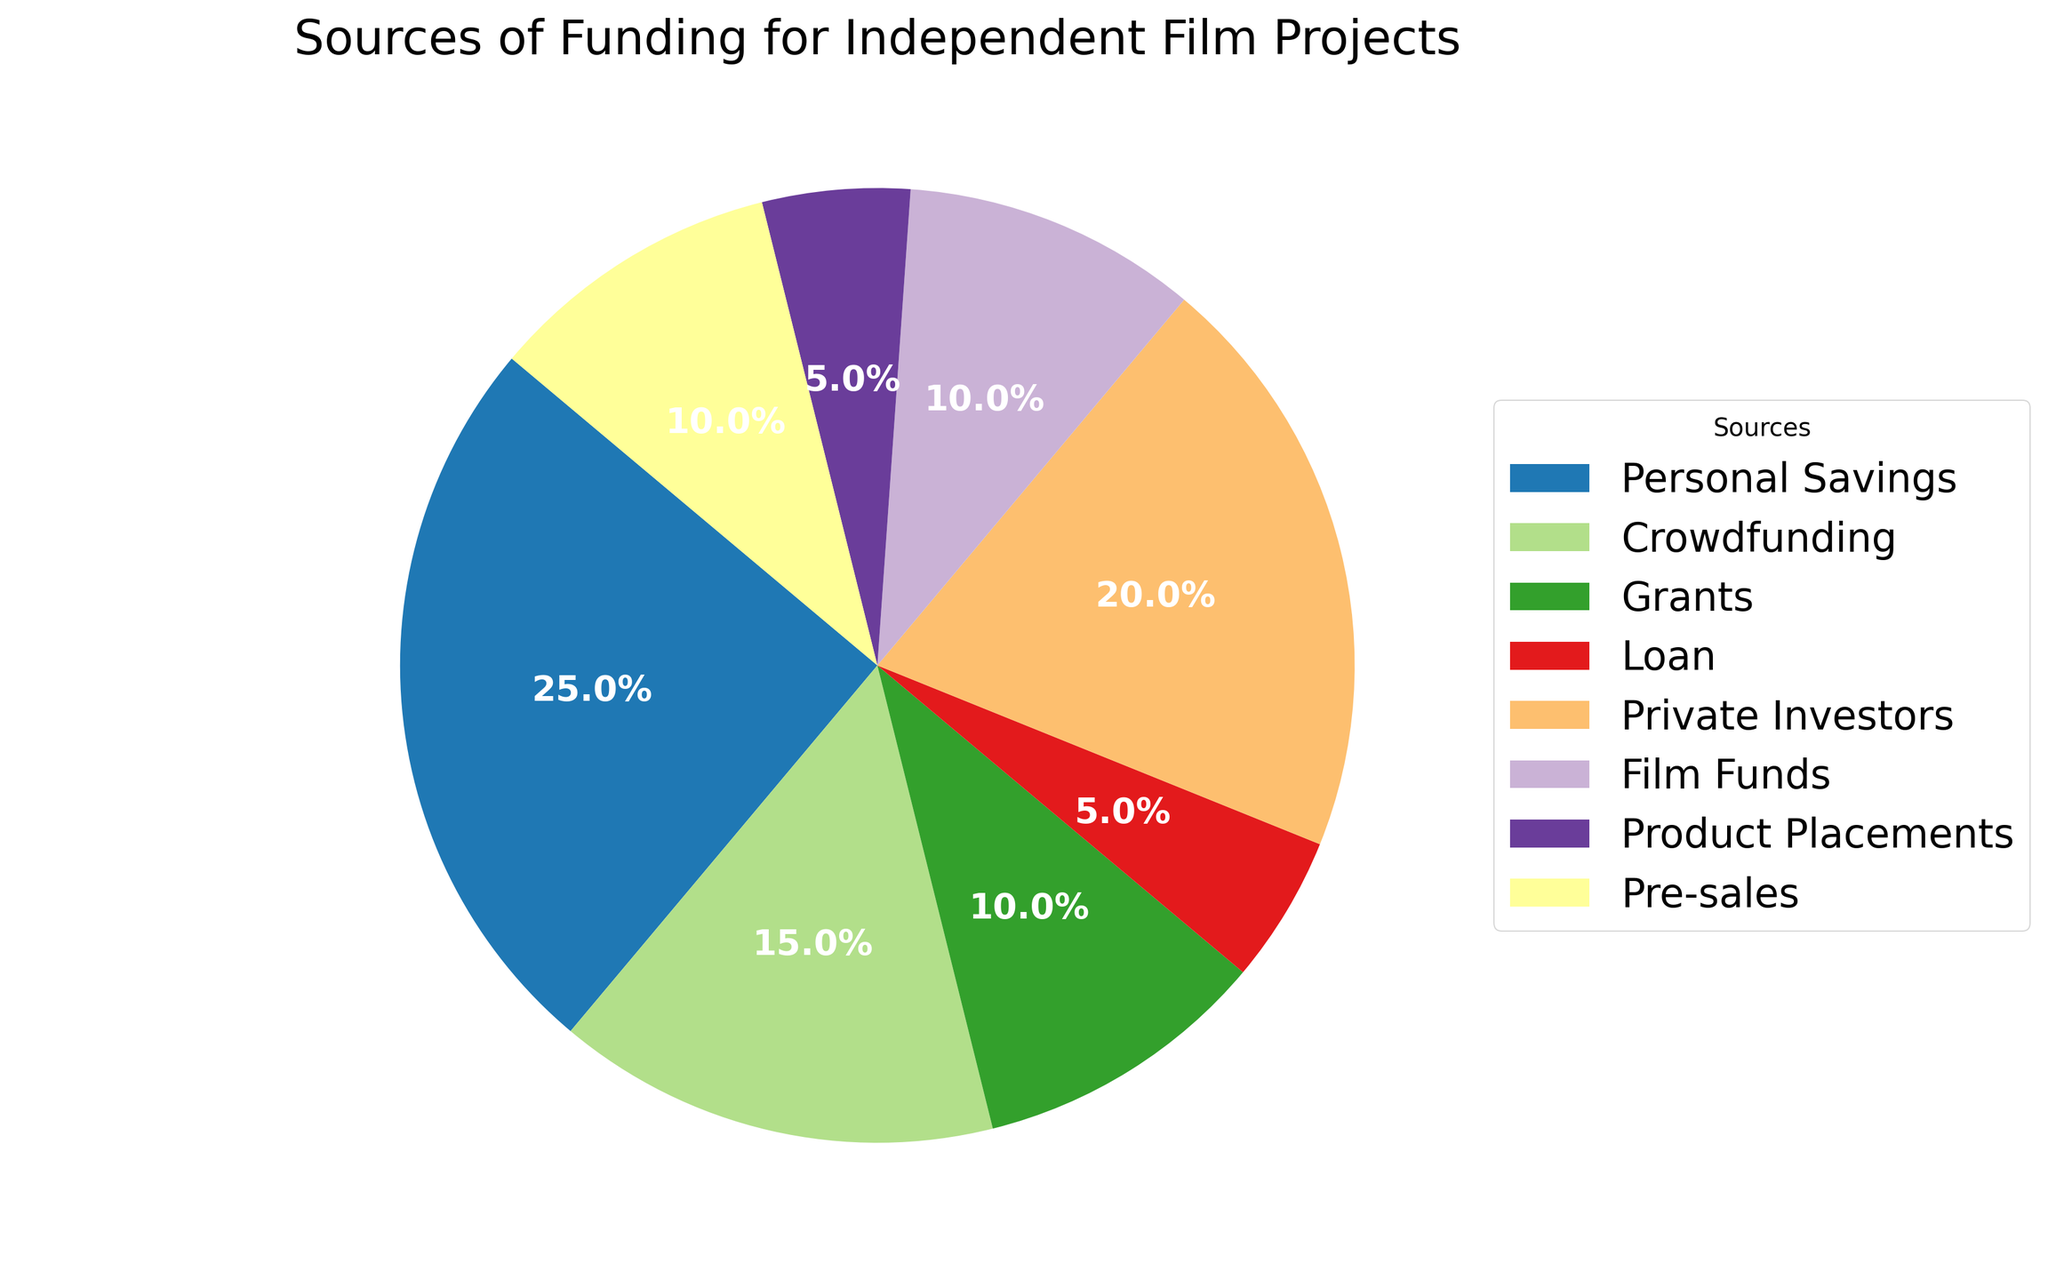What is the most common source of funding? The most common source of funding can be determined by identifying the segment with the highest percentage on the pie chart. "Personal Savings" holds 25%, which is the largest segment.
Answer: Personal Savings Which sources of funding each contribute exactly 10%? To find which sources contribute exactly 10%, we look at the segments labeled with a 10% share. Both "Grants," "Film Funds," and "Pre-sales" are labeled with 10%.
Answer: Grants, Film Funds, Pre-sales How much do the combined percentages of Crowdfunding and Private Investors contribute? To get the combined contribution of "Crowdfunding" and "Private Investors," we add their percentages: Crowdfunding (15%) + Private Investors (20%).
Answer: 35% Is the percentage contribution from Private Investors greater than that from Grants? By comparing the percentages, Private Investors (20%) is greater than Grants (10%).
Answer: Yes Which sources have the same percentage contribution? Identifying segments with the same percentage, both "Grants," "Film Funds," and "Pre-sales" share a contribution of 10%.
Answer: Grants, Film Funds, Pre-sales What is the total percentage contributed by sources other than the largest one? First, identify the largest contribution: "Personal Savings" is 25%. Subtract it from 100%: 100% - 25% = 75%.
Answer: 75% Which segment on the pie chart is the smallest in terms of percentage? By looking for the smallest percentage on the pie chart, "Loan" and "Product Placements" are both at 5%.
Answer: Loan, Product Placements Are there more sources contributing less than 15% or more than 15%? Count the sources contributing less than 15% (Grants, Loan, Film Funds, Product Placements, Pre-sales) which are 5. Then count those contributing more than 15% (Personal Savings, Private Investors, Crowdfunding), which are 3.
Answer: Less than What is the difference in percentage between Personal Savings and Crowdfunding? Subtract Crowdfunding's percentage from Personal Savings' percentage: 25% - 15% = 10%.
Answer: 10% What percentage of the total funding comes from sources that each contribute less than or equal to 10%? Adding the contributions of Grants (10%), Film Funds (10%), Pre-sales (10%), Loan (5%), and Product Placements (5%): 10% + 10% + 10% + 5% + 5% = 40%.
Answer: 40% 